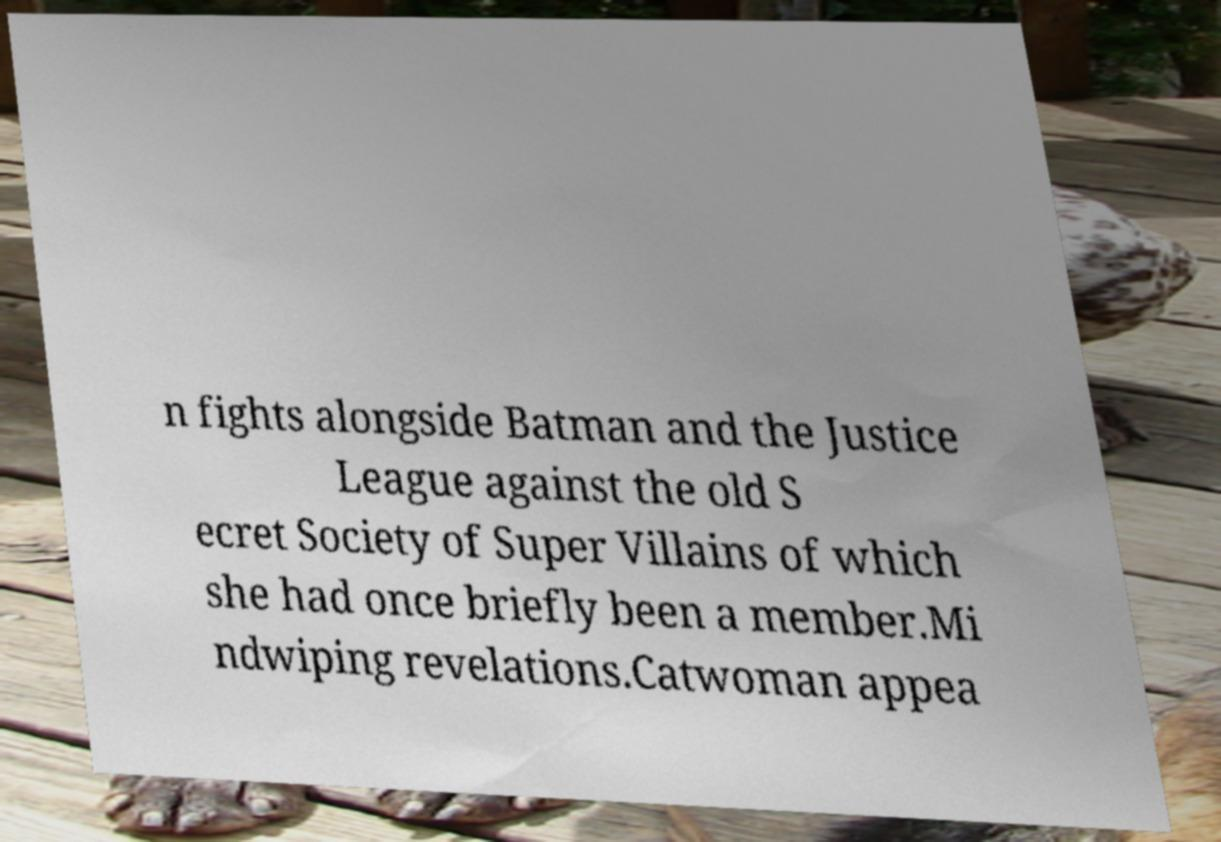Can you accurately transcribe the text from the provided image for me? n fights alongside Batman and the Justice League against the old S ecret Society of Super Villains of which she had once briefly been a member.Mi ndwiping revelations.Catwoman appea 